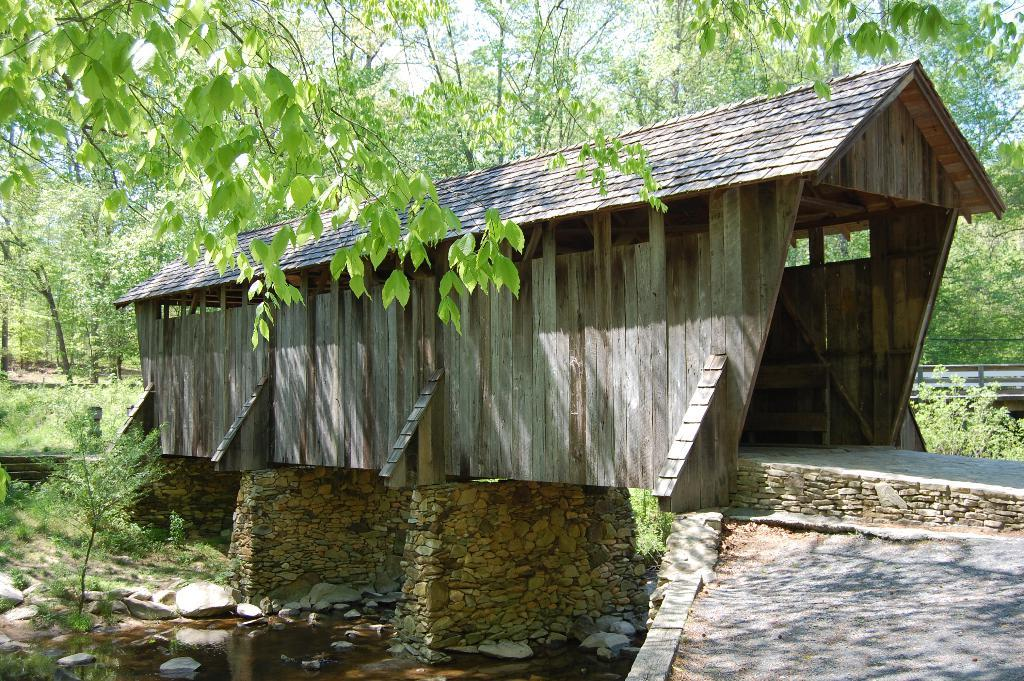What is the main subject of the image? There is a shark in the image. What is the environment surrounding the shark? There is water visible in the image. What other objects can be seen in the image? There are stones in the image. What can be seen in the background of the image? There are trees, plants, and a path visible in the background of the image. What type of songs can be heard coming from the shark in the image? There is no indication in the image that the shark is singing or making any sounds, so it's not possible to determine what songs might be heard. 